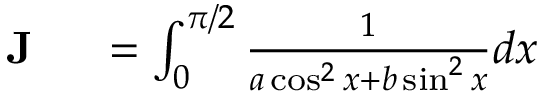<formula> <loc_0><loc_0><loc_500><loc_500>\begin{array} { r l } { J } & = \int _ { 0 } ^ { \pi / 2 } { \frac { 1 } { a \cos ^ { 2 } x + b \sin ^ { 2 } x } } d x } \end{array}</formula> 